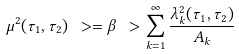<formula> <loc_0><loc_0><loc_500><loc_500>\mu ^ { 2 } ( \tau _ { 1 } , \tau _ { 2 } ) \ > = \beta \ > \sum _ { k = 1 } ^ { \infty } \frac { \lambda _ { k } ^ { 2 } ( \tau _ { 1 } , \tau _ { 2 } ) } { A _ { k } }</formula> 